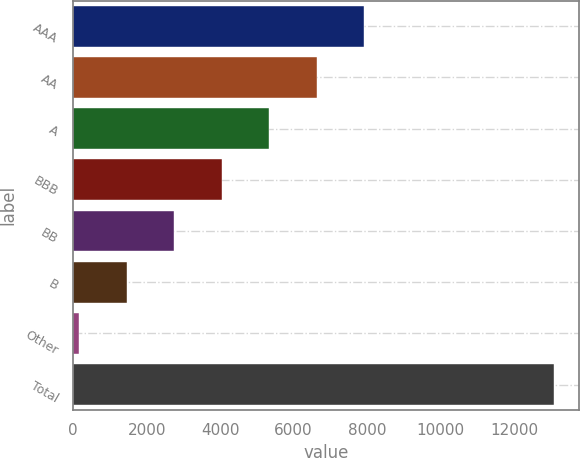Convert chart to OTSL. <chart><loc_0><loc_0><loc_500><loc_500><bar_chart><fcel>AAA<fcel>AA<fcel>A<fcel>BBB<fcel>BB<fcel>B<fcel>Other<fcel>Total<nl><fcel>7927.02<fcel>6633.5<fcel>5339.98<fcel>4046.46<fcel>2752.94<fcel>1459.42<fcel>165.9<fcel>13101.1<nl></chart> 